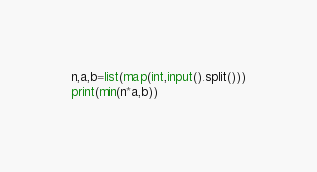Convert code to text. <code><loc_0><loc_0><loc_500><loc_500><_Python_>n,a,b=list(map(int,input().split()))
print(min(n*a,b))</code> 